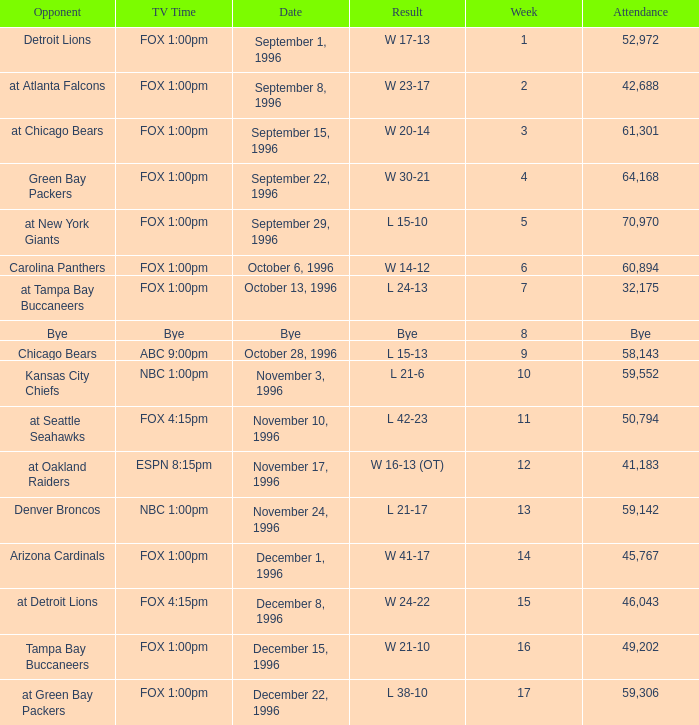Tell me the opponent for november 24, 1996 Denver Broncos. Could you parse the entire table as a dict? {'header': ['Opponent', 'TV Time', 'Date', 'Result', 'Week', 'Attendance'], 'rows': [['Detroit Lions', 'FOX 1:00pm', 'September 1, 1996', 'W 17-13', '1', '52,972'], ['at Atlanta Falcons', 'FOX 1:00pm', 'September 8, 1996', 'W 23-17', '2', '42,688'], ['at Chicago Bears', 'FOX 1:00pm', 'September 15, 1996', 'W 20-14', '3', '61,301'], ['Green Bay Packers', 'FOX 1:00pm', 'September 22, 1996', 'W 30-21', '4', '64,168'], ['at New York Giants', 'FOX 1:00pm', 'September 29, 1996', 'L 15-10', '5', '70,970'], ['Carolina Panthers', 'FOX 1:00pm', 'October 6, 1996', 'W 14-12', '6', '60,894'], ['at Tampa Bay Buccaneers', 'FOX 1:00pm', 'October 13, 1996', 'L 24-13', '7', '32,175'], ['Bye', 'Bye', 'Bye', 'Bye', '8', 'Bye'], ['Chicago Bears', 'ABC 9:00pm', 'October 28, 1996', 'L 15-13', '9', '58,143'], ['Kansas City Chiefs', 'NBC 1:00pm', 'November 3, 1996', 'L 21-6', '10', '59,552'], ['at Seattle Seahawks', 'FOX 4:15pm', 'November 10, 1996', 'L 42-23', '11', '50,794'], ['at Oakland Raiders', 'ESPN 8:15pm', 'November 17, 1996', 'W 16-13 (OT)', '12', '41,183'], ['Denver Broncos', 'NBC 1:00pm', 'November 24, 1996', 'L 21-17', '13', '59,142'], ['Arizona Cardinals', 'FOX 1:00pm', 'December 1, 1996', 'W 41-17', '14', '45,767'], ['at Detroit Lions', 'FOX 4:15pm', 'December 8, 1996', 'W 24-22', '15', '46,043'], ['Tampa Bay Buccaneers', 'FOX 1:00pm', 'December 15, 1996', 'W 21-10', '16', '49,202'], ['at Green Bay Packers', 'FOX 1:00pm', 'December 22, 1996', 'L 38-10', '17', '59,306']]} 